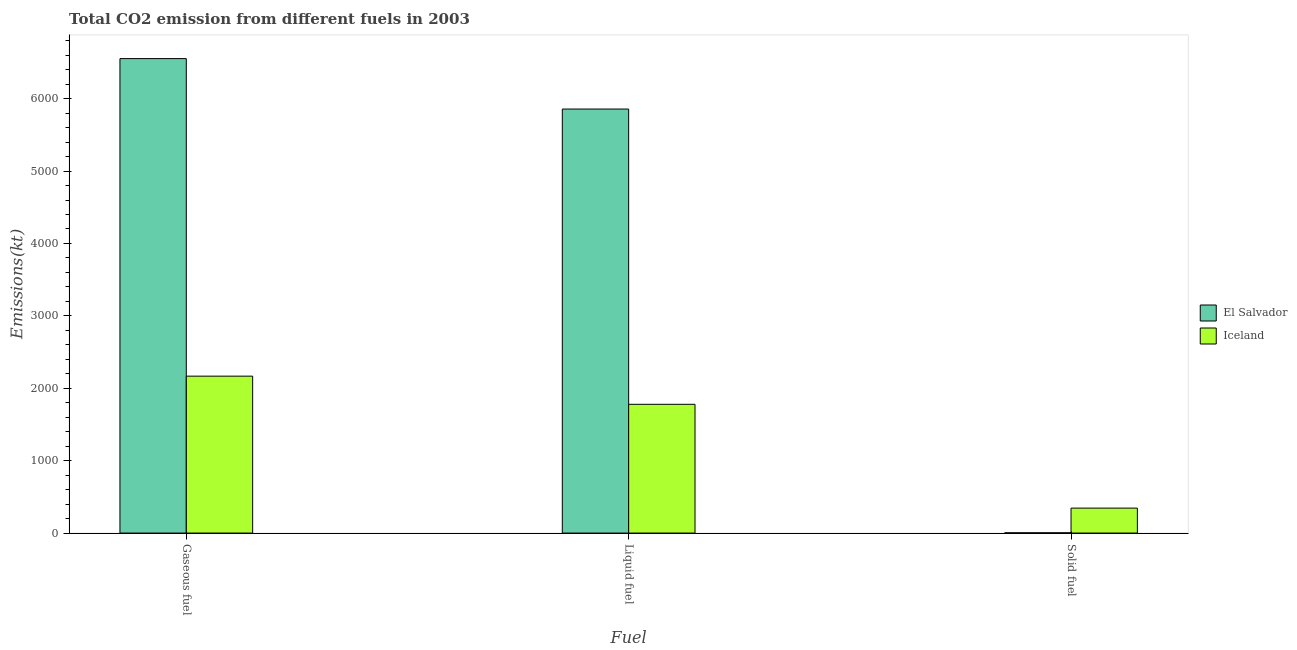How many bars are there on the 3rd tick from the left?
Your answer should be very brief. 2. How many bars are there on the 2nd tick from the right?
Provide a short and direct response. 2. What is the label of the 1st group of bars from the left?
Offer a very short reply. Gaseous fuel. What is the amount of co2 emissions from gaseous fuel in El Salvador?
Give a very brief answer. 6552.93. Across all countries, what is the maximum amount of co2 emissions from gaseous fuel?
Offer a very short reply. 6552.93. Across all countries, what is the minimum amount of co2 emissions from liquid fuel?
Give a very brief answer. 1778.49. In which country was the amount of co2 emissions from gaseous fuel maximum?
Offer a very short reply. El Salvador. What is the total amount of co2 emissions from gaseous fuel in the graph?
Ensure brevity in your answer.  8720.13. What is the difference between the amount of co2 emissions from liquid fuel in Iceland and that in El Salvador?
Give a very brief answer. -4077.7. What is the difference between the amount of co2 emissions from liquid fuel in Iceland and the amount of co2 emissions from gaseous fuel in El Salvador?
Make the answer very short. -4774.43. What is the average amount of co2 emissions from solid fuel per country?
Ensure brevity in your answer.  174.18. What is the difference between the amount of co2 emissions from solid fuel and amount of co2 emissions from gaseous fuel in El Salvador?
Offer a terse response. -6549.26. In how many countries, is the amount of co2 emissions from gaseous fuel greater than 4600 kt?
Keep it short and to the point. 1. What is the ratio of the amount of co2 emissions from solid fuel in El Salvador to that in Iceland?
Ensure brevity in your answer.  0.01. Is the amount of co2 emissions from solid fuel in Iceland less than that in El Salvador?
Give a very brief answer. No. Is the difference between the amount of co2 emissions from liquid fuel in El Salvador and Iceland greater than the difference between the amount of co2 emissions from solid fuel in El Salvador and Iceland?
Offer a very short reply. Yes. What is the difference between the highest and the second highest amount of co2 emissions from liquid fuel?
Your answer should be compact. 4077.7. What is the difference between the highest and the lowest amount of co2 emissions from solid fuel?
Provide a short and direct response. 341.03. In how many countries, is the amount of co2 emissions from gaseous fuel greater than the average amount of co2 emissions from gaseous fuel taken over all countries?
Offer a terse response. 1. What does the 1st bar from the left in Liquid fuel represents?
Your answer should be very brief. El Salvador. What does the 2nd bar from the right in Solid fuel represents?
Give a very brief answer. El Salvador. How many bars are there?
Keep it short and to the point. 6. Are the values on the major ticks of Y-axis written in scientific E-notation?
Your answer should be compact. No. Does the graph contain any zero values?
Provide a short and direct response. No. What is the title of the graph?
Your answer should be very brief. Total CO2 emission from different fuels in 2003. What is the label or title of the X-axis?
Provide a short and direct response. Fuel. What is the label or title of the Y-axis?
Your answer should be compact. Emissions(kt). What is the Emissions(kt) of El Salvador in Gaseous fuel?
Offer a very short reply. 6552.93. What is the Emissions(kt) in Iceland in Gaseous fuel?
Offer a terse response. 2167.2. What is the Emissions(kt) of El Salvador in Liquid fuel?
Your answer should be compact. 5856.2. What is the Emissions(kt) in Iceland in Liquid fuel?
Give a very brief answer. 1778.49. What is the Emissions(kt) in El Salvador in Solid fuel?
Give a very brief answer. 3.67. What is the Emissions(kt) in Iceland in Solid fuel?
Your response must be concise. 344.7. Across all Fuel, what is the maximum Emissions(kt) in El Salvador?
Your answer should be compact. 6552.93. Across all Fuel, what is the maximum Emissions(kt) of Iceland?
Give a very brief answer. 2167.2. Across all Fuel, what is the minimum Emissions(kt) in El Salvador?
Your response must be concise. 3.67. Across all Fuel, what is the minimum Emissions(kt) in Iceland?
Your answer should be very brief. 344.7. What is the total Emissions(kt) in El Salvador in the graph?
Give a very brief answer. 1.24e+04. What is the total Emissions(kt) in Iceland in the graph?
Ensure brevity in your answer.  4290.39. What is the difference between the Emissions(kt) in El Salvador in Gaseous fuel and that in Liquid fuel?
Offer a terse response. 696.73. What is the difference between the Emissions(kt) of Iceland in Gaseous fuel and that in Liquid fuel?
Your answer should be compact. 388.7. What is the difference between the Emissions(kt) of El Salvador in Gaseous fuel and that in Solid fuel?
Your answer should be compact. 6549.26. What is the difference between the Emissions(kt) of Iceland in Gaseous fuel and that in Solid fuel?
Keep it short and to the point. 1822.5. What is the difference between the Emissions(kt) of El Salvador in Liquid fuel and that in Solid fuel?
Make the answer very short. 5852.53. What is the difference between the Emissions(kt) in Iceland in Liquid fuel and that in Solid fuel?
Your answer should be compact. 1433.8. What is the difference between the Emissions(kt) of El Salvador in Gaseous fuel and the Emissions(kt) of Iceland in Liquid fuel?
Ensure brevity in your answer.  4774.43. What is the difference between the Emissions(kt) of El Salvador in Gaseous fuel and the Emissions(kt) of Iceland in Solid fuel?
Provide a succinct answer. 6208.23. What is the difference between the Emissions(kt) in El Salvador in Liquid fuel and the Emissions(kt) in Iceland in Solid fuel?
Ensure brevity in your answer.  5511.5. What is the average Emissions(kt) of El Salvador per Fuel?
Make the answer very short. 4137.6. What is the average Emissions(kt) of Iceland per Fuel?
Your answer should be very brief. 1430.13. What is the difference between the Emissions(kt) of El Salvador and Emissions(kt) of Iceland in Gaseous fuel?
Offer a terse response. 4385.73. What is the difference between the Emissions(kt) of El Salvador and Emissions(kt) of Iceland in Liquid fuel?
Your response must be concise. 4077.7. What is the difference between the Emissions(kt) of El Salvador and Emissions(kt) of Iceland in Solid fuel?
Make the answer very short. -341.03. What is the ratio of the Emissions(kt) of El Salvador in Gaseous fuel to that in Liquid fuel?
Your answer should be compact. 1.12. What is the ratio of the Emissions(kt) of Iceland in Gaseous fuel to that in Liquid fuel?
Keep it short and to the point. 1.22. What is the ratio of the Emissions(kt) in El Salvador in Gaseous fuel to that in Solid fuel?
Provide a succinct answer. 1787. What is the ratio of the Emissions(kt) in Iceland in Gaseous fuel to that in Solid fuel?
Your answer should be very brief. 6.29. What is the ratio of the Emissions(kt) of El Salvador in Liquid fuel to that in Solid fuel?
Keep it short and to the point. 1597. What is the ratio of the Emissions(kt) of Iceland in Liquid fuel to that in Solid fuel?
Give a very brief answer. 5.16. What is the difference between the highest and the second highest Emissions(kt) of El Salvador?
Offer a terse response. 696.73. What is the difference between the highest and the second highest Emissions(kt) of Iceland?
Offer a very short reply. 388.7. What is the difference between the highest and the lowest Emissions(kt) in El Salvador?
Provide a succinct answer. 6549.26. What is the difference between the highest and the lowest Emissions(kt) of Iceland?
Give a very brief answer. 1822.5. 